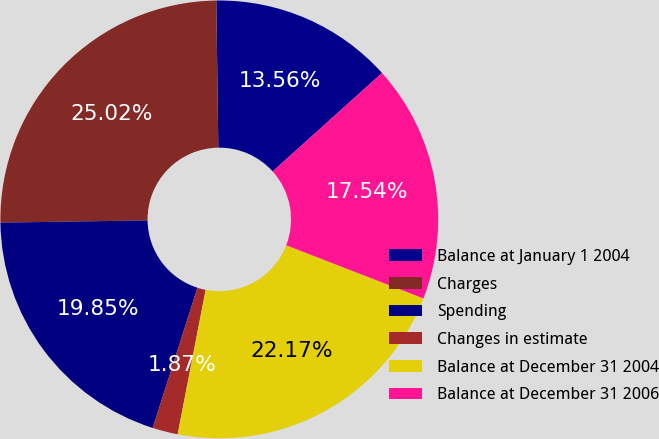Convert chart. <chart><loc_0><loc_0><loc_500><loc_500><pie_chart><fcel>Balance at January 1 2004<fcel>Charges<fcel>Spending<fcel>Changes in estimate<fcel>Balance at December 31 2004<fcel>Balance at December 31 2006<nl><fcel>13.56%<fcel>25.02%<fcel>19.85%<fcel>1.87%<fcel>22.17%<fcel>17.54%<nl></chart> 